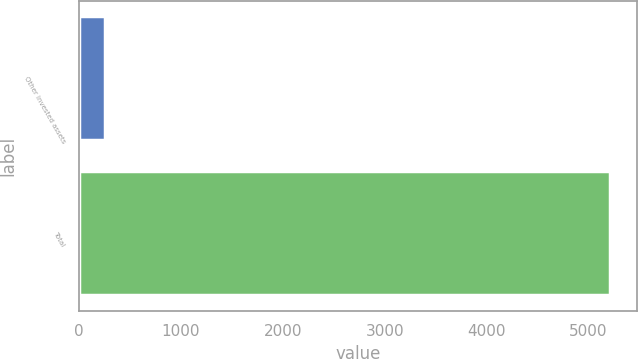<chart> <loc_0><loc_0><loc_500><loc_500><bar_chart><fcel>Other invested assets<fcel>Total<nl><fcel>251<fcel>5214<nl></chart> 